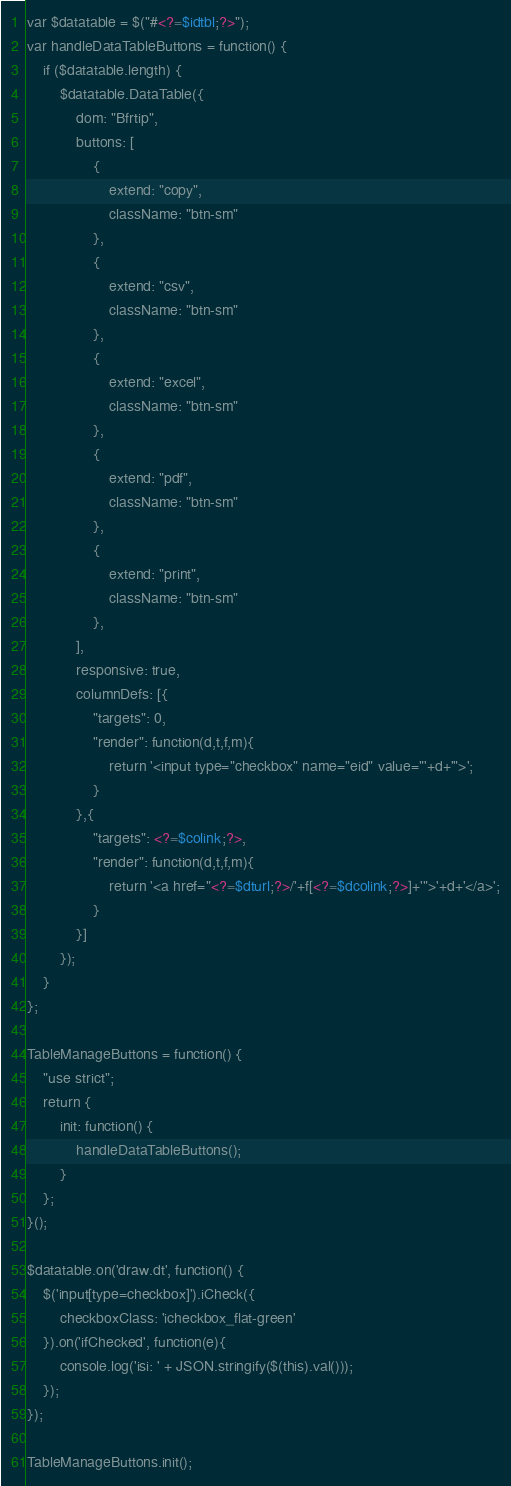Convert code to text. <code><loc_0><loc_0><loc_500><loc_500><_PHP_>var $datatable = $("#<?=$idtbl;?>");
var handleDataTableButtons = function() {
	if ($datatable.length) {
		$datatable.DataTable({
			dom: "Bfrtip",
			buttons: [
				{
					extend: "copy",
					className: "btn-sm"
				},
				{
					extend: "csv",
					className: "btn-sm"
				},
				{
					extend: "excel",
					className: "btn-sm"
				},
				{
					extend: "pdf",
					className: "btn-sm"
				},
				{
					extend: "print",
					className: "btn-sm"
				},
			],
			responsive: true,
			columnDefs: [{
				"targets": 0,
				"render": function(d,t,f,m){
					return '<input type="checkbox" name="eid" value="'+d+'">';
				}
			},{
				"targets": <?=$colink;?>,
				"render": function(d,t,f,m){
					return '<a href="<?=$dturl;?>/'+f[<?=$dcolink;?>]+'">'+d+'</a>';
				}
			}]
		});
	}
};

TableManageButtons = function() {
	"use strict";
	return {
		init: function() {
			handleDataTableButtons();
		}
	};
}();

$datatable.on('draw.dt', function() {
	$('input[type=checkbox]').iCheck({
		checkboxClass: 'icheckbox_flat-green'
	}).on('ifChecked', function(e){
		console.log('isi: ' + JSON.stringify($(this).val()));
	});
});

TableManageButtons.init();</code> 